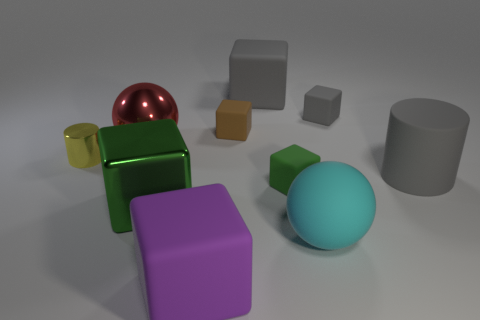Subtract all cyan balls. How many green cubes are left? 2 Subtract all purple cubes. How many cubes are left? 5 Subtract all green blocks. How many blocks are left? 4 Subtract all purple cubes. Subtract all brown cylinders. How many cubes are left? 5 Subtract all cylinders. How many objects are left? 8 Add 8 metallic blocks. How many metallic blocks are left? 9 Add 6 small red matte cylinders. How many small red matte cylinders exist? 6 Subtract 2 green blocks. How many objects are left? 8 Subtract all brown matte objects. Subtract all blocks. How many objects are left? 3 